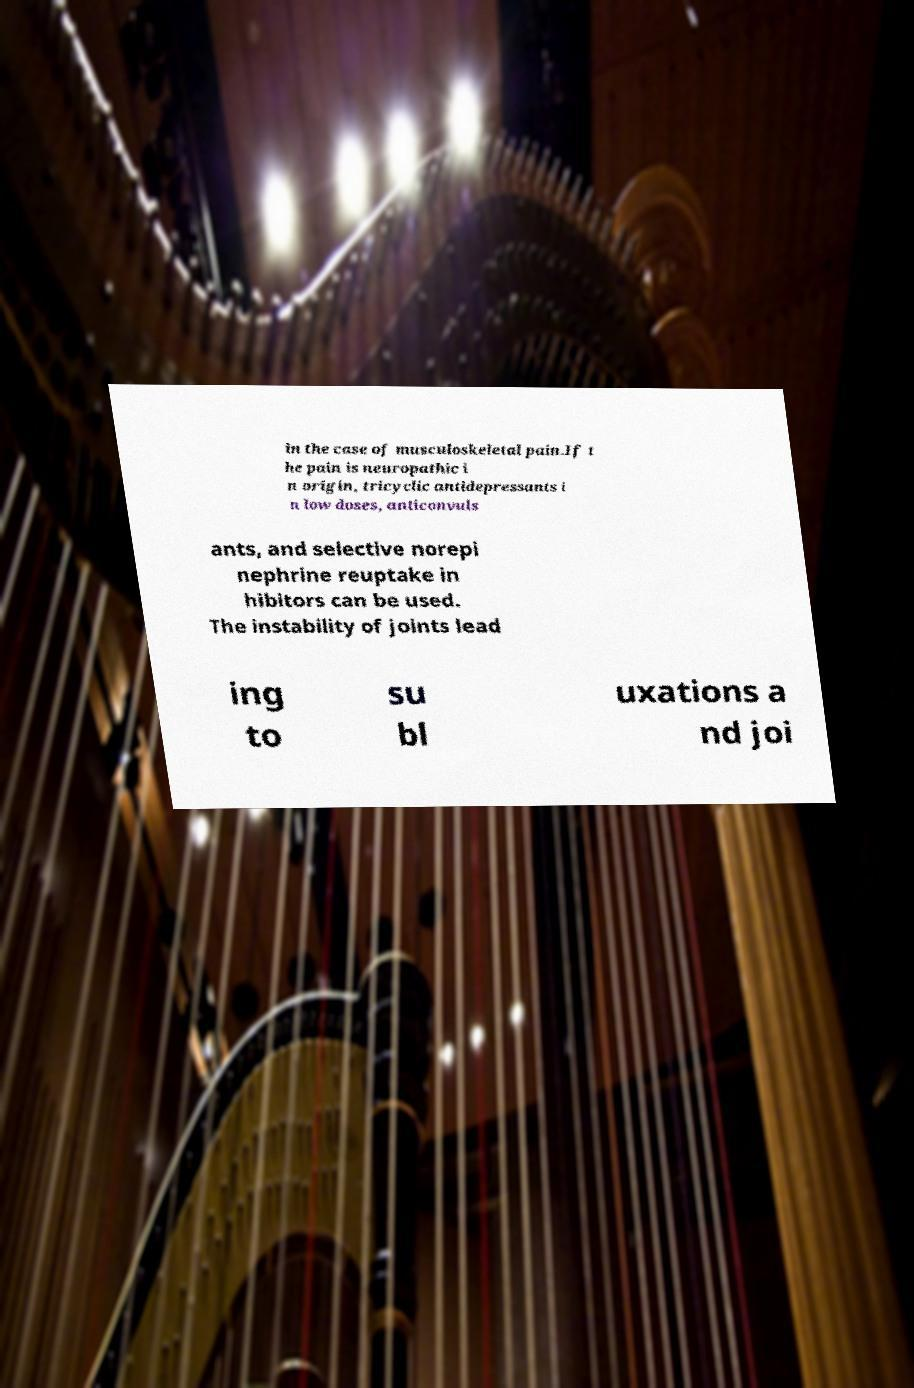Can you read and provide the text displayed in the image?This photo seems to have some interesting text. Can you extract and type it out for me? in the case of musculoskeletal pain.If t he pain is neuropathic i n origin, tricyclic antidepressants i n low doses, anticonvuls ants, and selective norepi nephrine reuptake in hibitors can be used. The instability of joints lead ing to su bl uxations a nd joi 